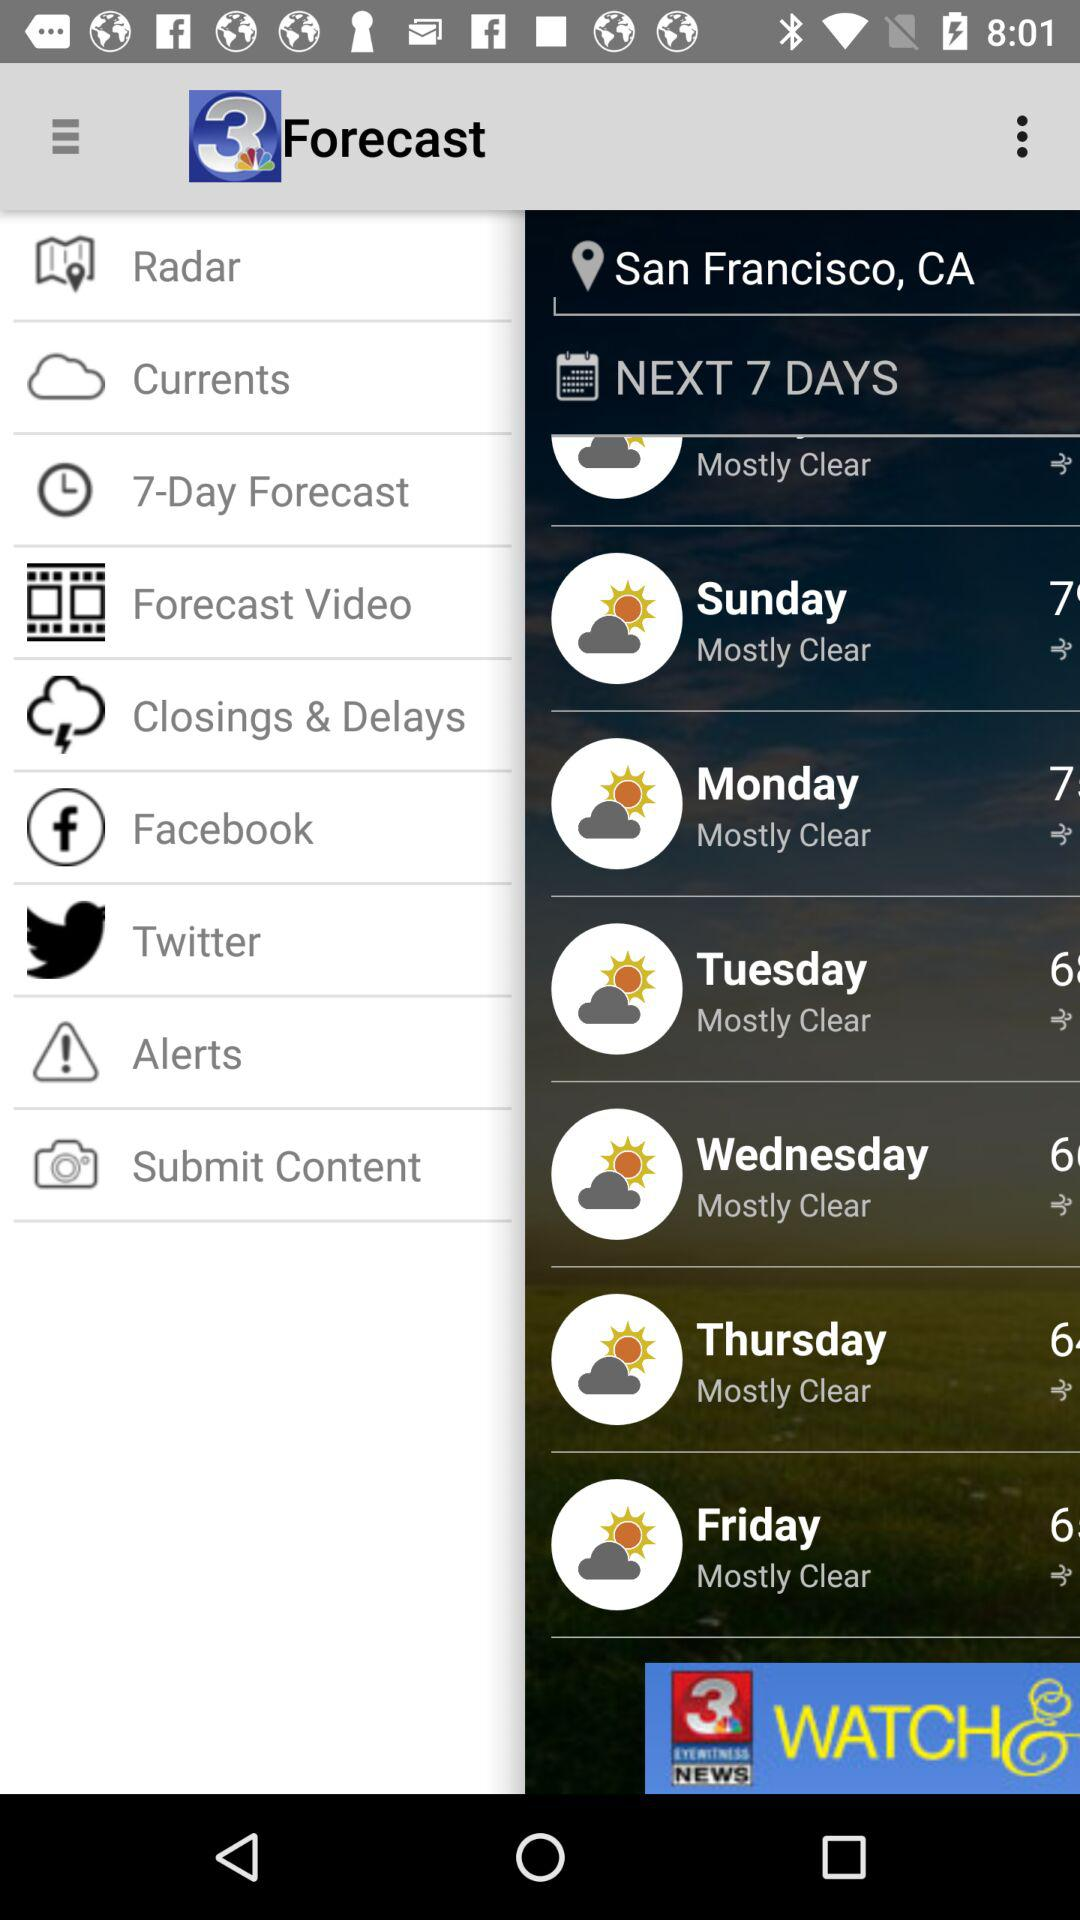What is the name of the application? The name of the application is "WSAV News - Savannah, GA". 